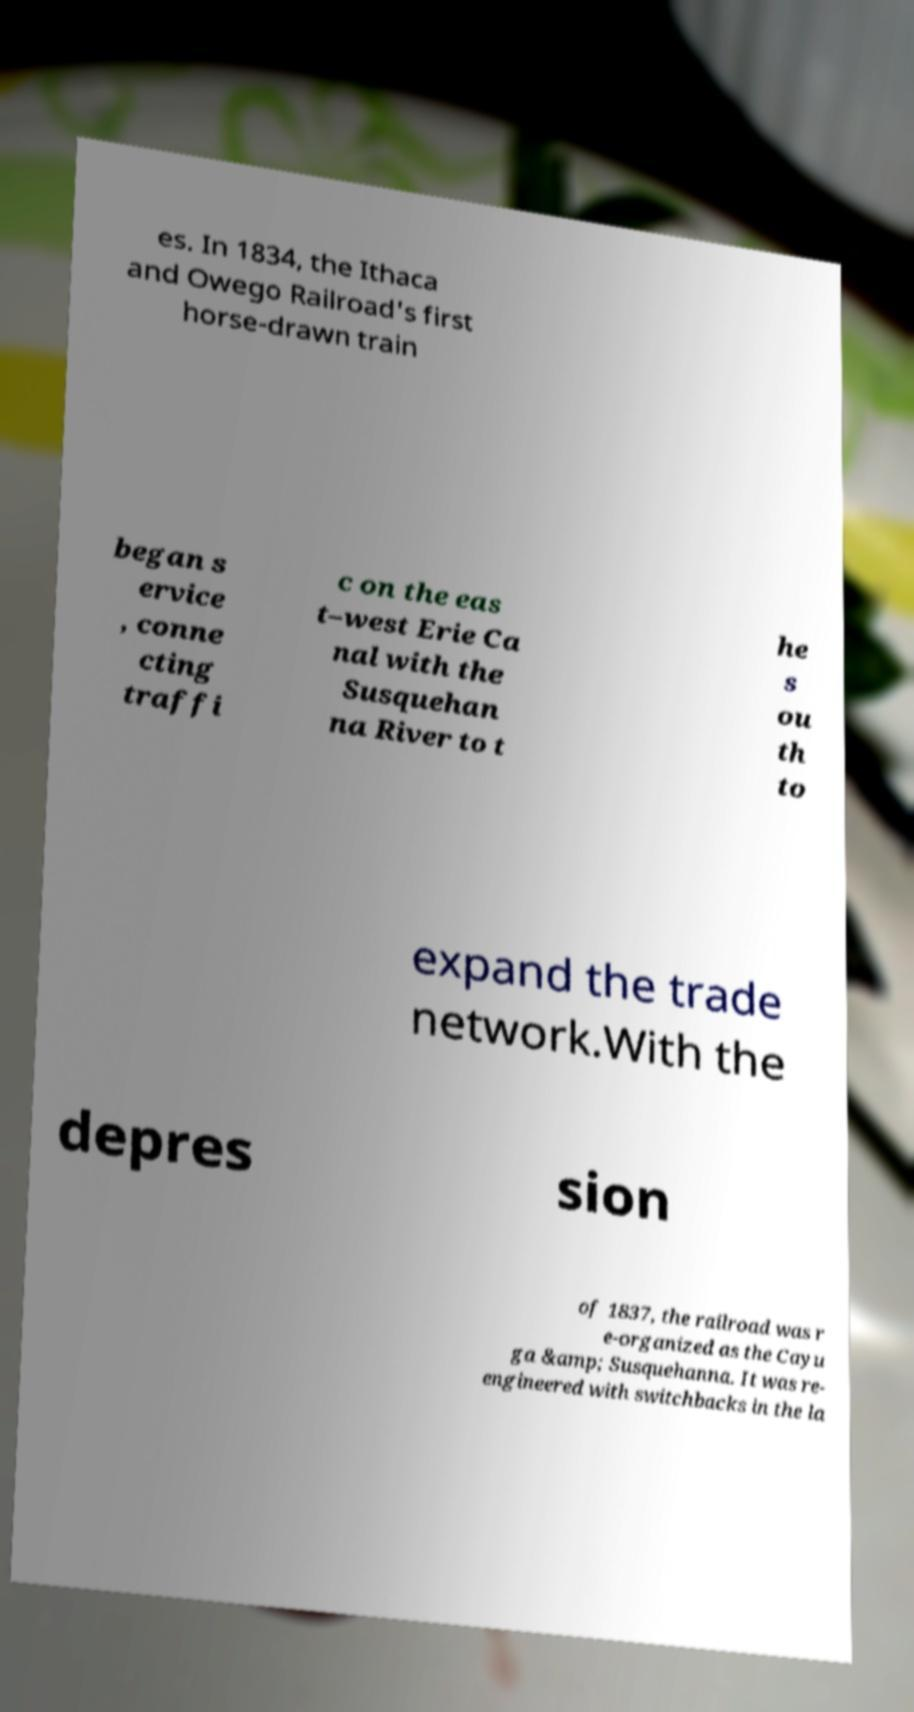Can you accurately transcribe the text from the provided image for me? es. In 1834, the Ithaca and Owego Railroad's first horse-drawn train began s ervice , conne cting traffi c on the eas t–west Erie Ca nal with the Susquehan na River to t he s ou th to expand the trade network.With the depres sion of 1837, the railroad was r e-organized as the Cayu ga &amp; Susquehanna. It was re- engineered with switchbacks in the la 